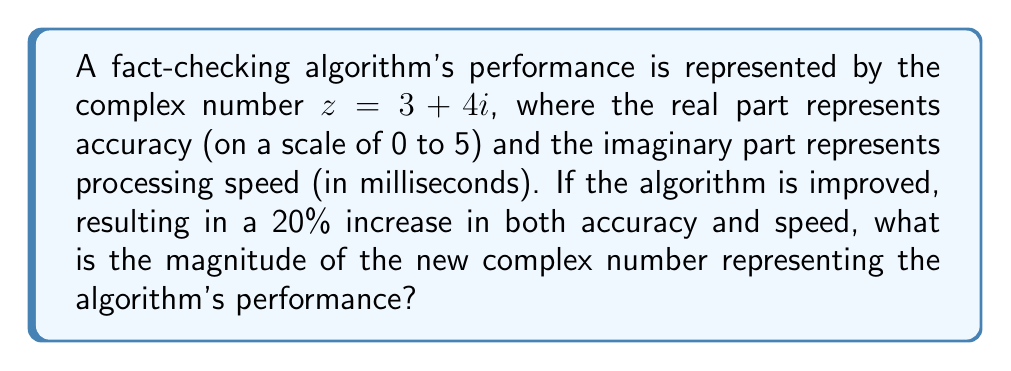Help me with this question. Let's approach this step-by-step:

1) The original complex number is $z = 3 + 4i$.

2) A 20% increase means multiplying each component by 1.2:
   New real part = $3 * 1.2 = 3.6$
   New imaginary part = $4 * 1.2 = 4.8$

3) The new complex number is $z_{new} = 3.6 + 4.8i$

4) To find the magnitude of this new complex number, we use the formula:
   $|z| = \sqrt{a^2 + b^2}$, where $a$ is the real part and $b$ is the imaginary part.

5) Substituting our values:
   $|z_{new}| = \sqrt{3.6^2 + 4.8^2}$

6) Calculate:
   $|z_{new}| = \sqrt{12.96 + 23.04}$
   $|z_{new}| = \sqrt{36}$
   $|z_{new}| = 6$

Therefore, the magnitude of the new complex number is 6.
Answer: $6$ 